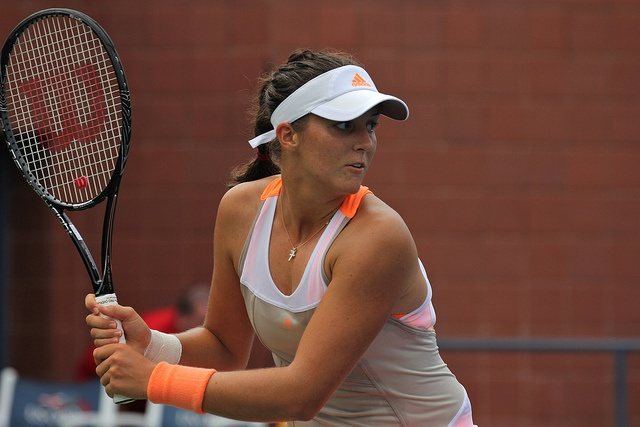Describe the objects in this image and their specific colors. I can see people in maroon, gray, and brown tones and tennis racket in maroon, black, darkgray, and gray tones in this image. 